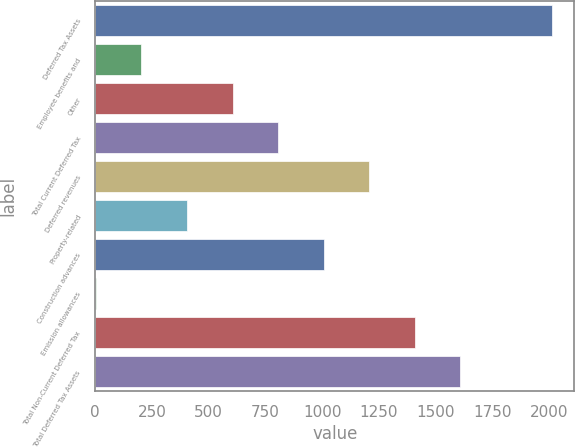Convert chart. <chart><loc_0><loc_0><loc_500><loc_500><bar_chart><fcel>Deferred Tax Assets<fcel>Employee benefits and<fcel>Other<fcel>Total Current Deferred Tax<fcel>Deferred revenues<fcel>Property-related<fcel>Construction advances<fcel>Emission allowances<fcel>Total Non-Current Deferred Tax<fcel>Total Deferred Tax Assets<nl><fcel>2010<fcel>203.34<fcel>604.82<fcel>805.56<fcel>1207.04<fcel>404.08<fcel>1006.3<fcel>2.6<fcel>1407.78<fcel>1608.52<nl></chart> 